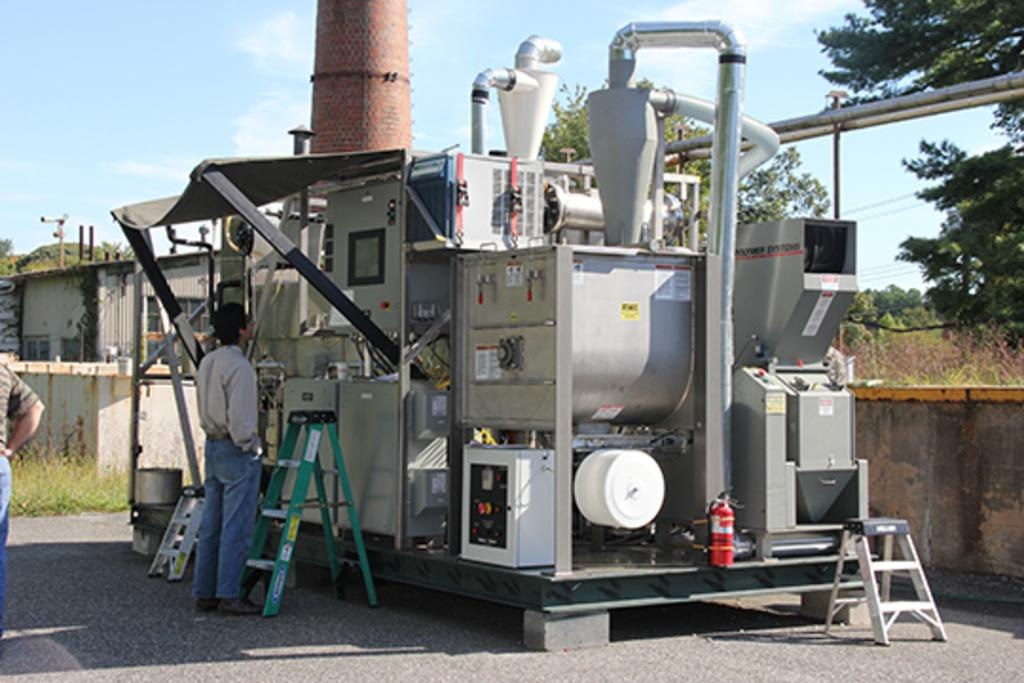What is the main object in the picture? There is a machine in the picture. Who or what is present near the machine? There are two persons standing at the left side of the picture. What can be seen in the background of the picture? There are plants, trees, and buildings in the backdrop of the picture. Can you see any nests in the picture? There are no nests visible in the picture. What type of cows can be seen grazing near the seashore in the image? There is no seashore or cows present in the image. 